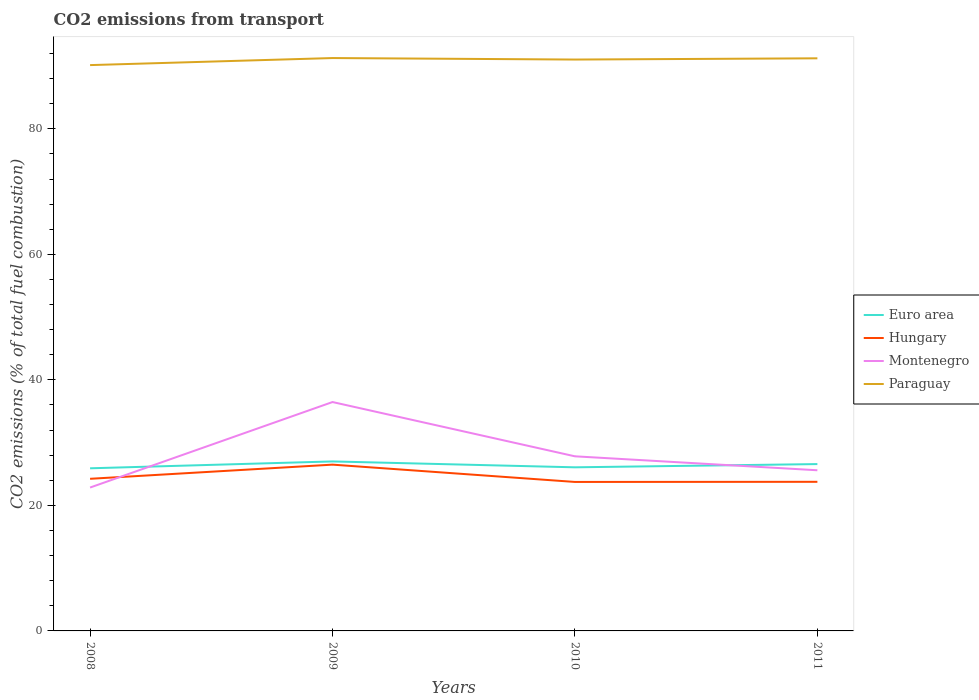How many different coloured lines are there?
Your response must be concise. 4. Does the line corresponding to Hungary intersect with the line corresponding to Montenegro?
Offer a very short reply. Yes. Is the number of lines equal to the number of legend labels?
Make the answer very short. Yes. Across all years, what is the maximum total CO2 emitted in Montenegro?
Give a very brief answer. 22.85. What is the total total CO2 emitted in Montenegro in the graph?
Your answer should be compact. 10.87. What is the difference between the highest and the second highest total CO2 emitted in Paraguay?
Make the answer very short. 1.12. Does the graph contain any zero values?
Provide a succinct answer. No. Does the graph contain grids?
Give a very brief answer. No. Where does the legend appear in the graph?
Your response must be concise. Center right. What is the title of the graph?
Make the answer very short. CO2 emissions from transport. What is the label or title of the Y-axis?
Your answer should be very brief. CO2 emissions (% of total fuel combustion). What is the CO2 emissions (% of total fuel combustion) of Euro area in 2008?
Provide a succinct answer. 25.91. What is the CO2 emissions (% of total fuel combustion) in Hungary in 2008?
Offer a terse response. 24.24. What is the CO2 emissions (% of total fuel combustion) in Montenegro in 2008?
Give a very brief answer. 22.85. What is the CO2 emissions (% of total fuel combustion) of Paraguay in 2008?
Your response must be concise. 90.16. What is the CO2 emissions (% of total fuel combustion) in Euro area in 2009?
Your response must be concise. 27.01. What is the CO2 emissions (% of total fuel combustion) of Hungary in 2009?
Keep it short and to the point. 26.5. What is the CO2 emissions (% of total fuel combustion) in Montenegro in 2009?
Make the answer very short. 36.47. What is the CO2 emissions (% of total fuel combustion) of Paraguay in 2009?
Your answer should be compact. 91.28. What is the CO2 emissions (% of total fuel combustion) of Euro area in 2010?
Provide a short and direct response. 26.07. What is the CO2 emissions (% of total fuel combustion) in Hungary in 2010?
Provide a succinct answer. 23.74. What is the CO2 emissions (% of total fuel combustion) of Montenegro in 2010?
Ensure brevity in your answer.  27.82. What is the CO2 emissions (% of total fuel combustion) in Paraguay in 2010?
Offer a terse response. 91.04. What is the CO2 emissions (% of total fuel combustion) of Euro area in 2011?
Keep it short and to the point. 26.58. What is the CO2 emissions (% of total fuel combustion) of Hungary in 2011?
Offer a terse response. 23.76. What is the CO2 emissions (% of total fuel combustion) in Montenegro in 2011?
Your response must be concise. 25.6. What is the CO2 emissions (% of total fuel combustion) of Paraguay in 2011?
Ensure brevity in your answer.  91.24. Across all years, what is the maximum CO2 emissions (% of total fuel combustion) of Euro area?
Offer a very short reply. 27.01. Across all years, what is the maximum CO2 emissions (% of total fuel combustion) of Hungary?
Provide a short and direct response. 26.5. Across all years, what is the maximum CO2 emissions (% of total fuel combustion) in Montenegro?
Provide a succinct answer. 36.47. Across all years, what is the maximum CO2 emissions (% of total fuel combustion) in Paraguay?
Offer a very short reply. 91.28. Across all years, what is the minimum CO2 emissions (% of total fuel combustion) of Euro area?
Your answer should be very brief. 25.91. Across all years, what is the minimum CO2 emissions (% of total fuel combustion) in Hungary?
Ensure brevity in your answer.  23.74. Across all years, what is the minimum CO2 emissions (% of total fuel combustion) in Montenegro?
Give a very brief answer. 22.85. Across all years, what is the minimum CO2 emissions (% of total fuel combustion) in Paraguay?
Offer a very short reply. 90.16. What is the total CO2 emissions (% of total fuel combustion) of Euro area in the graph?
Offer a very short reply. 105.57. What is the total CO2 emissions (% of total fuel combustion) in Hungary in the graph?
Your answer should be very brief. 98.23. What is the total CO2 emissions (% of total fuel combustion) in Montenegro in the graph?
Your answer should be very brief. 112.74. What is the total CO2 emissions (% of total fuel combustion) of Paraguay in the graph?
Provide a succinct answer. 363.73. What is the difference between the CO2 emissions (% of total fuel combustion) in Euro area in 2008 and that in 2009?
Provide a succinct answer. -1.09. What is the difference between the CO2 emissions (% of total fuel combustion) in Hungary in 2008 and that in 2009?
Your answer should be very brief. -2.25. What is the difference between the CO2 emissions (% of total fuel combustion) of Montenegro in 2008 and that in 2009?
Give a very brief answer. -13.62. What is the difference between the CO2 emissions (% of total fuel combustion) of Paraguay in 2008 and that in 2009?
Keep it short and to the point. -1.12. What is the difference between the CO2 emissions (% of total fuel combustion) in Euro area in 2008 and that in 2010?
Your response must be concise. -0.16. What is the difference between the CO2 emissions (% of total fuel combustion) in Hungary in 2008 and that in 2010?
Ensure brevity in your answer.  0.5. What is the difference between the CO2 emissions (% of total fuel combustion) of Montenegro in 2008 and that in 2010?
Keep it short and to the point. -4.98. What is the difference between the CO2 emissions (% of total fuel combustion) in Paraguay in 2008 and that in 2010?
Make the answer very short. -0.89. What is the difference between the CO2 emissions (% of total fuel combustion) in Euro area in 2008 and that in 2011?
Your response must be concise. -0.67. What is the difference between the CO2 emissions (% of total fuel combustion) in Hungary in 2008 and that in 2011?
Make the answer very short. 0.48. What is the difference between the CO2 emissions (% of total fuel combustion) in Montenegro in 2008 and that in 2011?
Provide a short and direct response. -2.75. What is the difference between the CO2 emissions (% of total fuel combustion) in Paraguay in 2008 and that in 2011?
Make the answer very short. -1.08. What is the difference between the CO2 emissions (% of total fuel combustion) in Euro area in 2009 and that in 2010?
Make the answer very short. 0.94. What is the difference between the CO2 emissions (% of total fuel combustion) in Hungary in 2009 and that in 2010?
Give a very brief answer. 2.76. What is the difference between the CO2 emissions (% of total fuel combustion) of Montenegro in 2009 and that in 2010?
Your answer should be compact. 8.65. What is the difference between the CO2 emissions (% of total fuel combustion) of Paraguay in 2009 and that in 2010?
Make the answer very short. 0.24. What is the difference between the CO2 emissions (% of total fuel combustion) in Euro area in 2009 and that in 2011?
Give a very brief answer. 0.42. What is the difference between the CO2 emissions (% of total fuel combustion) of Hungary in 2009 and that in 2011?
Make the answer very short. 2.73. What is the difference between the CO2 emissions (% of total fuel combustion) in Montenegro in 2009 and that in 2011?
Keep it short and to the point. 10.87. What is the difference between the CO2 emissions (% of total fuel combustion) in Paraguay in 2009 and that in 2011?
Offer a very short reply. 0.04. What is the difference between the CO2 emissions (% of total fuel combustion) of Euro area in 2010 and that in 2011?
Your response must be concise. -0.52. What is the difference between the CO2 emissions (% of total fuel combustion) in Hungary in 2010 and that in 2011?
Provide a short and direct response. -0.02. What is the difference between the CO2 emissions (% of total fuel combustion) of Montenegro in 2010 and that in 2011?
Your answer should be very brief. 2.22. What is the difference between the CO2 emissions (% of total fuel combustion) in Paraguay in 2010 and that in 2011?
Offer a very short reply. -0.2. What is the difference between the CO2 emissions (% of total fuel combustion) of Euro area in 2008 and the CO2 emissions (% of total fuel combustion) of Hungary in 2009?
Give a very brief answer. -0.58. What is the difference between the CO2 emissions (% of total fuel combustion) in Euro area in 2008 and the CO2 emissions (% of total fuel combustion) in Montenegro in 2009?
Your answer should be compact. -10.56. What is the difference between the CO2 emissions (% of total fuel combustion) of Euro area in 2008 and the CO2 emissions (% of total fuel combustion) of Paraguay in 2009?
Provide a succinct answer. -65.37. What is the difference between the CO2 emissions (% of total fuel combustion) in Hungary in 2008 and the CO2 emissions (% of total fuel combustion) in Montenegro in 2009?
Your response must be concise. -12.23. What is the difference between the CO2 emissions (% of total fuel combustion) of Hungary in 2008 and the CO2 emissions (% of total fuel combustion) of Paraguay in 2009?
Make the answer very short. -67.04. What is the difference between the CO2 emissions (% of total fuel combustion) in Montenegro in 2008 and the CO2 emissions (% of total fuel combustion) in Paraguay in 2009?
Your answer should be very brief. -68.44. What is the difference between the CO2 emissions (% of total fuel combustion) in Euro area in 2008 and the CO2 emissions (% of total fuel combustion) in Hungary in 2010?
Provide a short and direct response. 2.17. What is the difference between the CO2 emissions (% of total fuel combustion) of Euro area in 2008 and the CO2 emissions (% of total fuel combustion) of Montenegro in 2010?
Make the answer very short. -1.91. What is the difference between the CO2 emissions (% of total fuel combustion) in Euro area in 2008 and the CO2 emissions (% of total fuel combustion) in Paraguay in 2010?
Offer a very short reply. -65.13. What is the difference between the CO2 emissions (% of total fuel combustion) of Hungary in 2008 and the CO2 emissions (% of total fuel combustion) of Montenegro in 2010?
Your answer should be compact. -3.58. What is the difference between the CO2 emissions (% of total fuel combustion) in Hungary in 2008 and the CO2 emissions (% of total fuel combustion) in Paraguay in 2010?
Keep it short and to the point. -66.8. What is the difference between the CO2 emissions (% of total fuel combustion) of Montenegro in 2008 and the CO2 emissions (% of total fuel combustion) of Paraguay in 2010?
Ensure brevity in your answer.  -68.2. What is the difference between the CO2 emissions (% of total fuel combustion) in Euro area in 2008 and the CO2 emissions (% of total fuel combustion) in Hungary in 2011?
Provide a succinct answer. 2.15. What is the difference between the CO2 emissions (% of total fuel combustion) in Euro area in 2008 and the CO2 emissions (% of total fuel combustion) in Montenegro in 2011?
Offer a terse response. 0.31. What is the difference between the CO2 emissions (% of total fuel combustion) of Euro area in 2008 and the CO2 emissions (% of total fuel combustion) of Paraguay in 2011?
Make the answer very short. -65.33. What is the difference between the CO2 emissions (% of total fuel combustion) of Hungary in 2008 and the CO2 emissions (% of total fuel combustion) of Montenegro in 2011?
Offer a terse response. -1.36. What is the difference between the CO2 emissions (% of total fuel combustion) in Hungary in 2008 and the CO2 emissions (% of total fuel combustion) in Paraguay in 2011?
Ensure brevity in your answer.  -67. What is the difference between the CO2 emissions (% of total fuel combustion) in Montenegro in 2008 and the CO2 emissions (% of total fuel combustion) in Paraguay in 2011?
Your answer should be very brief. -68.4. What is the difference between the CO2 emissions (% of total fuel combustion) in Euro area in 2009 and the CO2 emissions (% of total fuel combustion) in Hungary in 2010?
Keep it short and to the point. 3.27. What is the difference between the CO2 emissions (% of total fuel combustion) in Euro area in 2009 and the CO2 emissions (% of total fuel combustion) in Montenegro in 2010?
Give a very brief answer. -0.82. What is the difference between the CO2 emissions (% of total fuel combustion) of Euro area in 2009 and the CO2 emissions (% of total fuel combustion) of Paraguay in 2010?
Keep it short and to the point. -64.04. What is the difference between the CO2 emissions (% of total fuel combustion) in Hungary in 2009 and the CO2 emissions (% of total fuel combustion) in Montenegro in 2010?
Keep it short and to the point. -1.33. What is the difference between the CO2 emissions (% of total fuel combustion) of Hungary in 2009 and the CO2 emissions (% of total fuel combustion) of Paraguay in 2010?
Offer a terse response. -64.55. What is the difference between the CO2 emissions (% of total fuel combustion) in Montenegro in 2009 and the CO2 emissions (% of total fuel combustion) in Paraguay in 2010?
Ensure brevity in your answer.  -54.57. What is the difference between the CO2 emissions (% of total fuel combustion) in Euro area in 2009 and the CO2 emissions (% of total fuel combustion) in Hungary in 2011?
Ensure brevity in your answer.  3.25. What is the difference between the CO2 emissions (% of total fuel combustion) in Euro area in 2009 and the CO2 emissions (% of total fuel combustion) in Montenegro in 2011?
Ensure brevity in your answer.  1.41. What is the difference between the CO2 emissions (% of total fuel combustion) of Euro area in 2009 and the CO2 emissions (% of total fuel combustion) of Paraguay in 2011?
Provide a short and direct response. -64.24. What is the difference between the CO2 emissions (% of total fuel combustion) of Hungary in 2009 and the CO2 emissions (% of total fuel combustion) of Montenegro in 2011?
Make the answer very short. 0.9. What is the difference between the CO2 emissions (% of total fuel combustion) in Hungary in 2009 and the CO2 emissions (% of total fuel combustion) in Paraguay in 2011?
Your response must be concise. -64.75. What is the difference between the CO2 emissions (% of total fuel combustion) in Montenegro in 2009 and the CO2 emissions (% of total fuel combustion) in Paraguay in 2011?
Ensure brevity in your answer.  -54.77. What is the difference between the CO2 emissions (% of total fuel combustion) in Euro area in 2010 and the CO2 emissions (% of total fuel combustion) in Hungary in 2011?
Offer a very short reply. 2.31. What is the difference between the CO2 emissions (% of total fuel combustion) of Euro area in 2010 and the CO2 emissions (% of total fuel combustion) of Montenegro in 2011?
Your response must be concise. 0.47. What is the difference between the CO2 emissions (% of total fuel combustion) in Euro area in 2010 and the CO2 emissions (% of total fuel combustion) in Paraguay in 2011?
Give a very brief answer. -65.17. What is the difference between the CO2 emissions (% of total fuel combustion) in Hungary in 2010 and the CO2 emissions (% of total fuel combustion) in Montenegro in 2011?
Provide a succinct answer. -1.86. What is the difference between the CO2 emissions (% of total fuel combustion) of Hungary in 2010 and the CO2 emissions (% of total fuel combustion) of Paraguay in 2011?
Make the answer very short. -67.5. What is the difference between the CO2 emissions (% of total fuel combustion) of Montenegro in 2010 and the CO2 emissions (% of total fuel combustion) of Paraguay in 2011?
Offer a very short reply. -63.42. What is the average CO2 emissions (% of total fuel combustion) of Euro area per year?
Offer a very short reply. 26.39. What is the average CO2 emissions (% of total fuel combustion) of Hungary per year?
Give a very brief answer. 24.56. What is the average CO2 emissions (% of total fuel combustion) in Montenegro per year?
Provide a short and direct response. 28.18. What is the average CO2 emissions (% of total fuel combustion) of Paraguay per year?
Your answer should be compact. 90.93. In the year 2008, what is the difference between the CO2 emissions (% of total fuel combustion) of Euro area and CO2 emissions (% of total fuel combustion) of Hungary?
Your answer should be compact. 1.67. In the year 2008, what is the difference between the CO2 emissions (% of total fuel combustion) in Euro area and CO2 emissions (% of total fuel combustion) in Montenegro?
Make the answer very short. 3.07. In the year 2008, what is the difference between the CO2 emissions (% of total fuel combustion) in Euro area and CO2 emissions (% of total fuel combustion) in Paraguay?
Keep it short and to the point. -64.25. In the year 2008, what is the difference between the CO2 emissions (% of total fuel combustion) of Hungary and CO2 emissions (% of total fuel combustion) of Montenegro?
Offer a very short reply. 1.39. In the year 2008, what is the difference between the CO2 emissions (% of total fuel combustion) in Hungary and CO2 emissions (% of total fuel combustion) in Paraguay?
Your answer should be very brief. -65.92. In the year 2008, what is the difference between the CO2 emissions (% of total fuel combustion) of Montenegro and CO2 emissions (% of total fuel combustion) of Paraguay?
Your answer should be very brief. -67.31. In the year 2009, what is the difference between the CO2 emissions (% of total fuel combustion) of Euro area and CO2 emissions (% of total fuel combustion) of Hungary?
Your answer should be compact. 0.51. In the year 2009, what is the difference between the CO2 emissions (% of total fuel combustion) in Euro area and CO2 emissions (% of total fuel combustion) in Montenegro?
Keep it short and to the point. -9.46. In the year 2009, what is the difference between the CO2 emissions (% of total fuel combustion) of Euro area and CO2 emissions (% of total fuel combustion) of Paraguay?
Offer a terse response. -64.28. In the year 2009, what is the difference between the CO2 emissions (% of total fuel combustion) of Hungary and CO2 emissions (% of total fuel combustion) of Montenegro?
Give a very brief answer. -9.98. In the year 2009, what is the difference between the CO2 emissions (% of total fuel combustion) of Hungary and CO2 emissions (% of total fuel combustion) of Paraguay?
Offer a very short reply. -64.79. In the year 2009, what is the difference between the CO2 emissions (% of total fuel combustion) in Montenegro and CO2 emissions (% of total fuel combustion) in Paraguay?
Your answer should be compact. -54.81. In the year 2010, what is the difference between the CO2 emissions (% of total fuel combustion) in Euro area and CO2 emissions (% of total fuel combustion) in Hungary?
Ensure brevity in your answer.  2.33. In the year 2010, what is the difference between the CO2 emissions (% of total fuel combustion) in Euro area and CO2 emissions (% of total fuel combustion) in Montenegro?
Provide a short and direct response. -1.75. In the year 2010, what is the difference between the CO2 emissions (% of total fuel combustion) of Euro area and CO2 emissions (% of total fuel combustion) of Paraguay?
Make the answer very short. -64.98. In the year 2010, what is the difference between the CO2 emissions (% of total fuel combustion) in Hungary and CO2 emissions (% of total fuel combustion) in Montenegro?
Your response must be concise. -4.08. In the year 2010, what is the difference between the CO2 emissions (% of total fuel combustion) in Hungary and CO2 emissions (% of total fuel combustion) in Paraguay?
Offer a terse response. -67.31. In the year 2010, what is the difference between the CO2 emissions (% of total fuel combustion) in Montenegro and CO2 emissions (% of total fuel combustion) in Paraguay?
Your response must be concise. -63.22. In the year 2011, what is the difference between the CO2 emissions (% of total fuel combustion) in Euro area and CO2 emissions (% of total fuel combustion) in Hungary?
Offer a terse response. 2.82. In the year 2011, what is the difference between the CO2 emissions (% of total fuel combustion) in Euro area and CO2 emissions (% of total fuel combustion) in Montenegro?
Keep it short and to the point. 0.98. In the year 2011, what is the difference between the CO2 emissions (% of total fuel combustion) of Euro area and CO2 emissions (% of total fuel combustion) of Paraguay?
Your answer should be very brief. -64.66. In the year 2011, what is the difference between the CO2 emissions (% of total fuel combustion) in Hungary and CO2 emissions (% of total fuel combustion) in Montenegro?
Your answer should be compact. -1.84. In the year 2011, what is the difference between the CO2 emissions (% of total fuel combustion) of Hungary and CO2 emissions (% of total fuel combustion) of Paraguay?
Offer a terse response. -67.48. In the year 2011, what is the difference between the CO2 emissions (% of total fuel combustion) of Montenegro and CO2 emissions (% of total fuel combustion) of Paraguay?
Make the answer very short. -65.64. What is the ratio of the CO2 emissions (% of total fuel combustion) in Euro area in 2008 to that in 2009?
Ensure brevity in your answer.  0.96. What is the ratio of the CO2 emissions (% of total fuel combustion) of Hungary in 2008 to that in 2009?
Your answer should be compact. 0.91. What is the ratio of the CO2 emissions (% of total fuel combustion) of Montenegro in 2008 to that in 2009?
Provide a succinct answer. 0.63. What is the ratio of the CO2 emissions (% of total fuel combustion) of Paraguay in 2008 to that in 2009?
Make the answer very short. 0.99. What is the ratio of the CO2 emissions (% of total fuel combustion) in Hungary in 2008 to that in 2010?
Your response must be concise. 1.02. What is the ratio of the CO2 emissions (% of total fuel combustion) in Montenegro in 2008 to that in 2010?
Your response must be concise. 0.82. What is the ratio of the CO2 emissions (% of total fuel combustion) in Paraguay in 2008 to that in 2010?
Offer a very short reply. 0.99. What is the ratio of the CO2 emissions (% of total fuel combustion) of Euro area in 2008 to that in 2011?
Offer a very short reply. 0.97. What is the ratio of the CO2 emissions (% of total fuel combustion) of Hungary in 2008 to that in 2011?
Offer a terse response. 1.02. What is the ratio of the CO2 emissions (% of total fuel combustion) in Montenegro in 2008 to that in 2011?
Your answer should be very brief. 0.89. What is the ratio of the CO2 emissions (% of total fuel combustion) in Paraguay in 2008 to that in 2011?
Make the answer very short. 0.99. What is the ratio of the CO2 emissions (% of total fuel combustion) of Euro area in 2009 to that in 2010?
Provide a succinct answer. 1.04. What is the ratio of the CO2 emissions (% of total fuel combustion) of Hungary in 2009 to that in 2010?
Offer a very short reply. 1.12. What is the ratio of the CO2 emissions (% of total fuel combustion) of Montenegro in 2009 to that in 2010?
Offer a very short reply. 1.31. What is the ratio of the CO2 emissions (% of total fuel combustion) in Paraguay in 2009 to that in 2010?
Provide a succinct answer. 1. What is the ratio of the CO2 emissions (% of total fuel combustion) of Euro area in 2009 to that in 2011?
Offer a very short reply. 1.02. What is the ratio of the CO2 emissions (% of total fuel combustion) of Hungary in 2009 to that in 2011?
Your answer should be very brief. 1.12. What is the ratio of the CO2 emissions (% of total fuel combustion) in Montenegro in 2009 to that in 2011?
Give a very brief answer. 1.42. What is the ratio of the CO2 emissions (% of total fuel combustion) in Paraguay in 2009 to that in 2011?
Offer a terse response. 1. What is the ratio of the CO2 emissions (% of total fuel combustion) in Euro area in 2010 to that in 2011?
Give a very brief answer. 0.98. What is the ratio of the CO2 emissions (% of total fuel combustion) of Hungary in 2010 to that in 2011?
Provide a short and direct response. 1. What is the ratio of the CO2 emissions (% of total fuel combustion) of Montenegro in 2010 to that in 2011?
Give a very brief answer. 1.09. What is the ratio of the CO2 emissions (% of total fuel combustion) in Paraguay in 2010 to that in 2011?
Provide a short and direct response. 1. What is the difference between the highest and the second highest CO2 emissions (% of total fuel combustion) in Euro area?
Your answer should be compact. 0.42. What is the difference between the highest and the second highest CO2 emissions (% of total fuel combustion) in Hungary?
Make the answer very short. 2.25. What is the difference between the highest and the second highest CO2 emissions (% of total fuel combustion) of Montenegro?
Ensure brevity in your answer.  8.65. What is the difference between the highest and the second highest CO2 emissions (% of total fuel combustion) of Paraguay?
Give a very brief answer. 0.04. What is the difference between the highest and the lowest CO2 emissions (% of total fuel combustion) in Euro area?
Keep it short and to the point. 1.09. What is the difference between the highest and the lowest CO2 emissions (% of total fuel combustion) in Hungary?
Keep it short and to the point. 2.76. What is the difference between the highest and the lowest CO2 emissions (% of total fuel combustion) in Montenegro?
Offer a very short reply. 13.62. What is the difference between the highest and the lowest CO2 emissions (% of total fuel combustion) of Paraguay?
Keep it short and to the point. 1.12. 